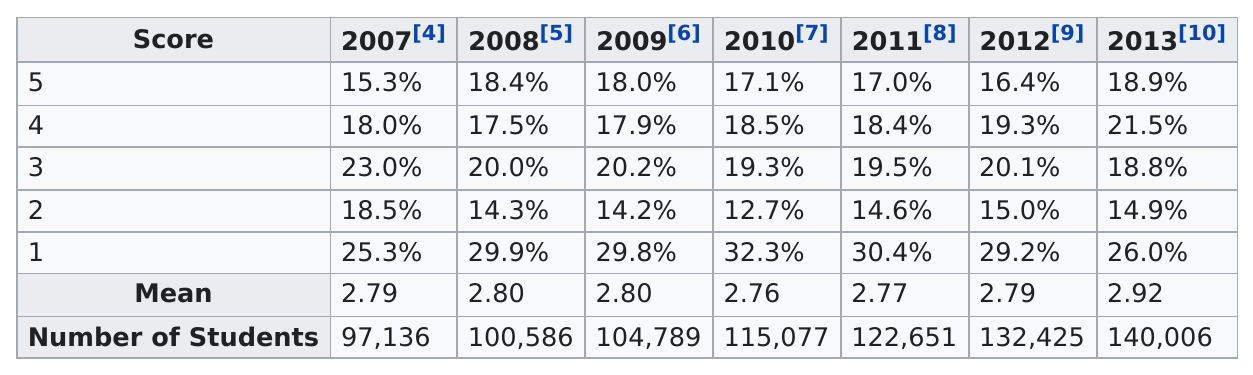Highlight a few significant elements in this photo. In 2013, the total number of students testing was the greatest among the two years, 2008 and 2013. In the year 2007, there were 97,136 students who took the test. In 2012, a total of 132,425 students took the test. The score that had the highest percentage of students in it consecutively each year was 1. In 2009, the number of students who scored a 5 on the test was 0.1% less than the number of students who scored a 4 on the test. 